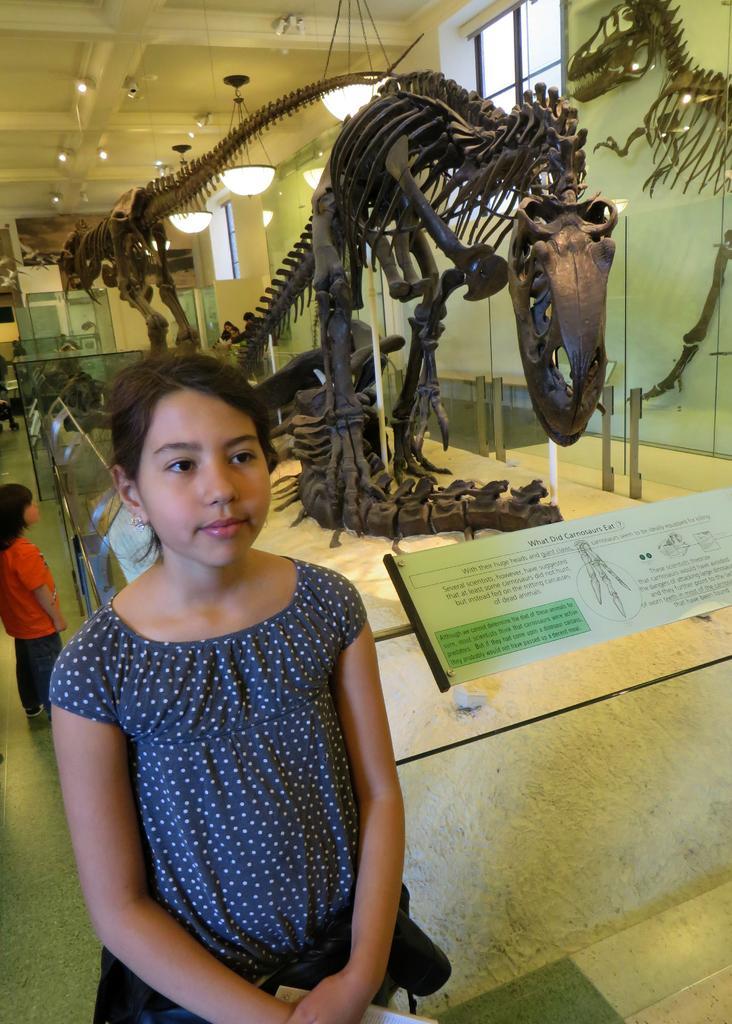Describe this image in one or two sentences. In this image I can see two people with navy blue and an orange color dresses. To the side of these people I can see the statues of animals and the board. In the background I can see the lights and the window. 